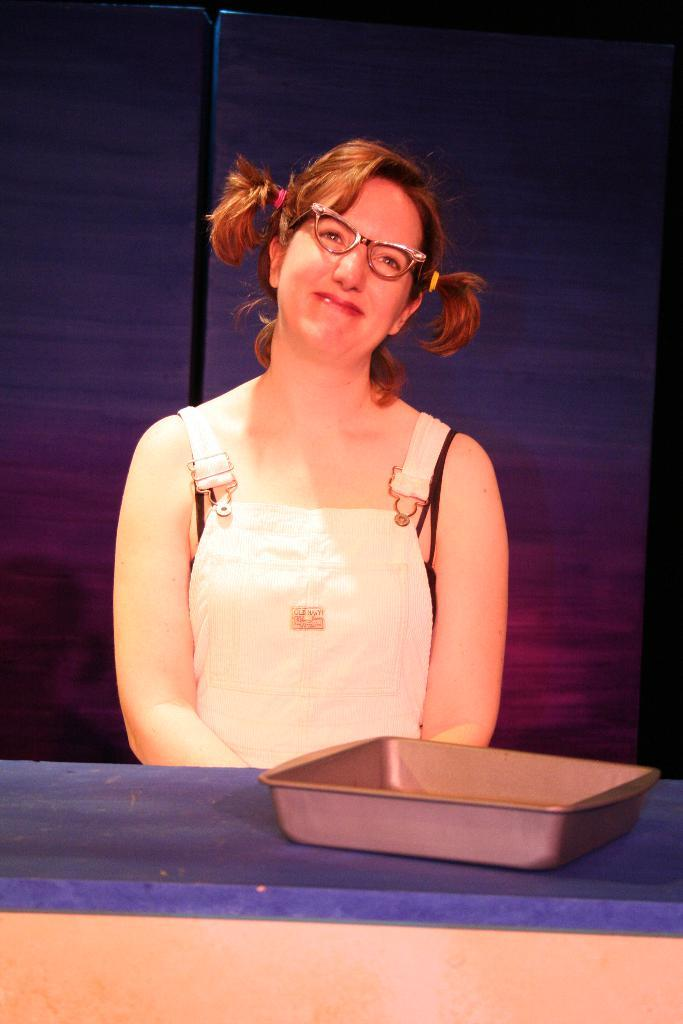What is the woman in the image doing? The woman is sitting in the image. What is in front of the woman? There is a table in front of the woman. What is on the table? There is a tray on the table. What can be observed about the background of the image? The background of the image is dark. What type of battle is depicted in the image? There is no battle present in the image. 